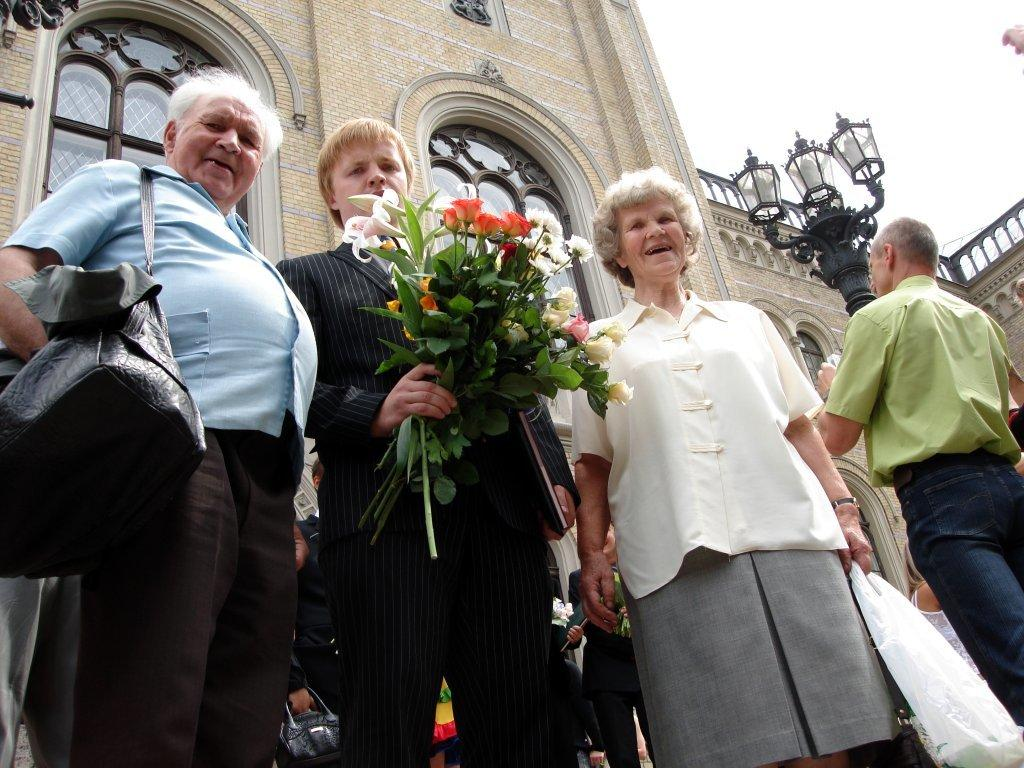Where was the image taken? The image was clicked outside. What can be seen in the middle of the image? There is a building in the middle of the image. What is present on the right side of the image? There are lights on the right side of the image. How many people are in the middle of the image? There are 4 persons in the middle of the image. What is one of the persons holding? One of the persons is holding flowers. Can you see a fan in the image? There is no fan present in the image. Is there a robin perched on the building in the image? There is no robin visible in the image. 